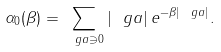Convert formula to latex. <formula><loc_0><loc_0><loc_500><loc_500>\alpha _ { 0 } ( \beta ) = \sum _ { \ g a \ni 0 } | \ g a | \, e ^ { - \beta | \ g a | } .</formula> 